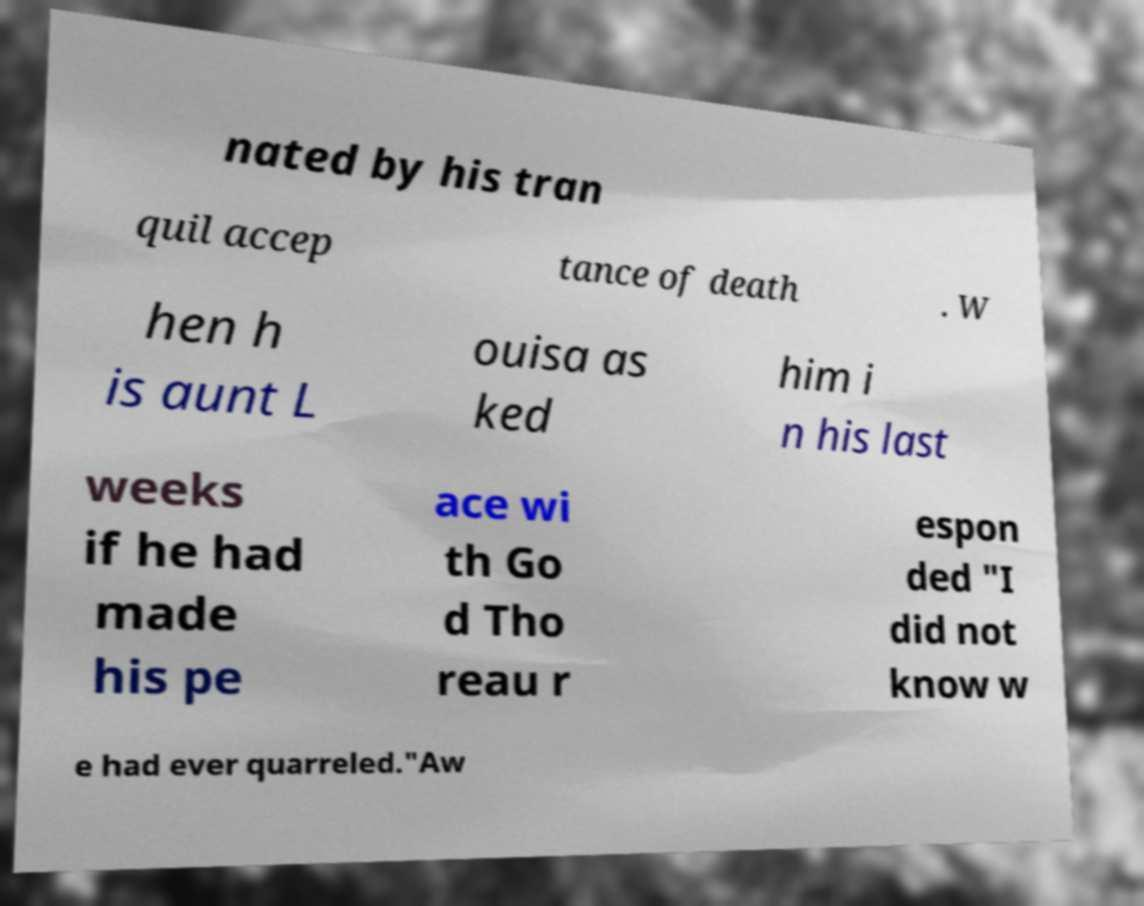I need the written content from this picture converted into text. Can you do that? nated by his tran quil accep tance of death . W hen h is aunt L ouisa as ked him i n his last weeks if he had made his pe ace wi th Go d Tho reau r espon ded "I did not know w e had ever quarreled."Aw 